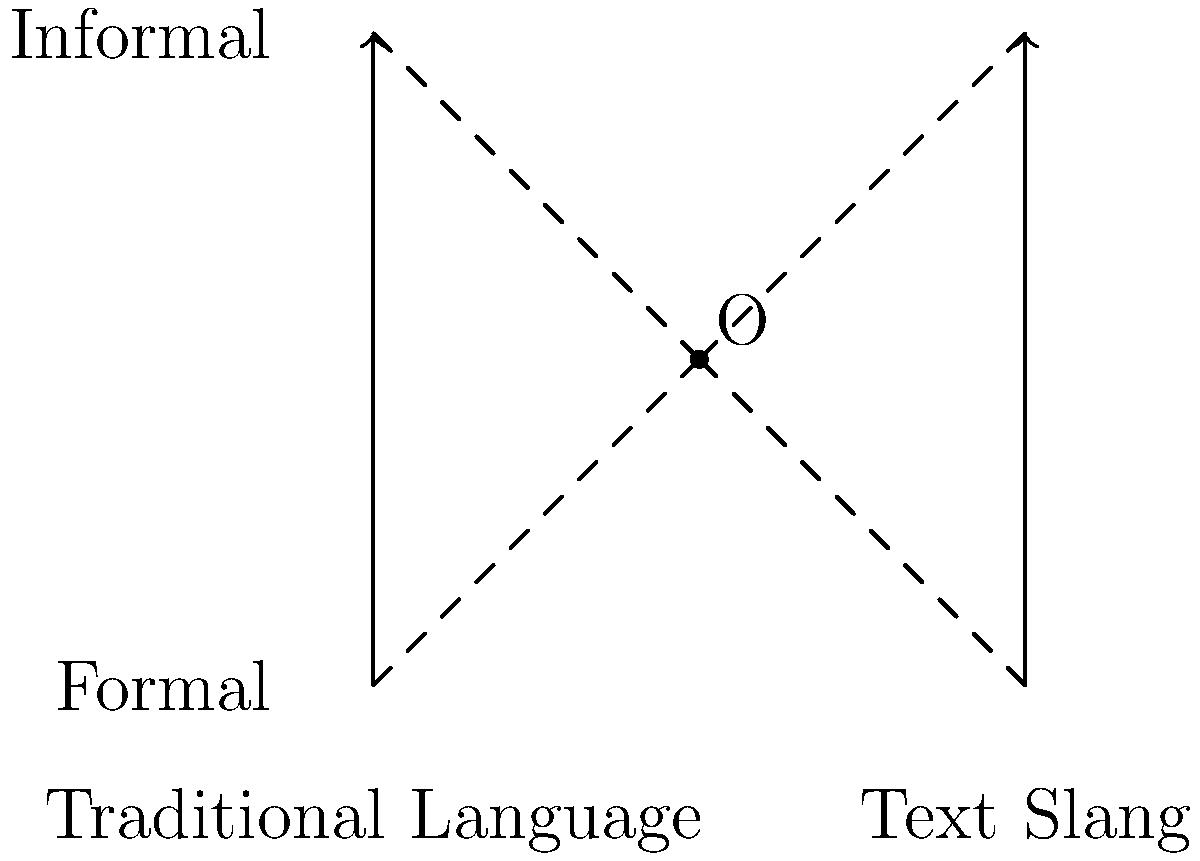In the diagram above, two perpendicular lines intersect at point O, representing the evolution of language. The x-axis represents the spectrum from traditional language to text slang, while the y-axis represents the formality of language. If the distance from O to any of the four extremes (A, B, C, D) is 2 units, what is the area of the square ABCD? How does this relate to the perceived degradation of language through texting slang? To solve this problem and relate it to language evolution, let's follow these steps:

1) First, we need to calculate the side length of the square ABCD. 
   Given that O is the center of the square and the distance from O to any vertex is 2 units, we can deduce that each side of the square is 4 units long.

2) The area of a square is calculated by squaring the length of its side. 
   Therefore, the area of ABCD = $4^2 = 16$ square units.

3) Now, let's relate this to language evolution:
   - The x-axis represents the spectrum from traditional language (at A) to text slang (at B).
   - The y-axis represents the formality of language, from formal (at A) to informal (at C).

4) The intersection point O represents a balance between these extremes.

5) The equal distance (2 units) from O to each extreme suggests that language naturally seeks equilibrium.

6) However, from the perspective of a sociolinguist concerned about language degradation:
   - The movement from A (traditional, formal) to D (slang, informal) represents a perceived degradation.
   - The equal areas in each quadrant might be interpreted as the rapid spread of informal text slang, encroaching on traditional language spaces.

7) The total area (16 square units) could symbolize the entirety of language usage. The sociolinguist might argue that a significant portion (the upper right quadrant) is now occupied by informal text slang, supporting the claim of language degradation.
Answer: 16 square units; represents equal influence of text slang on language space. 